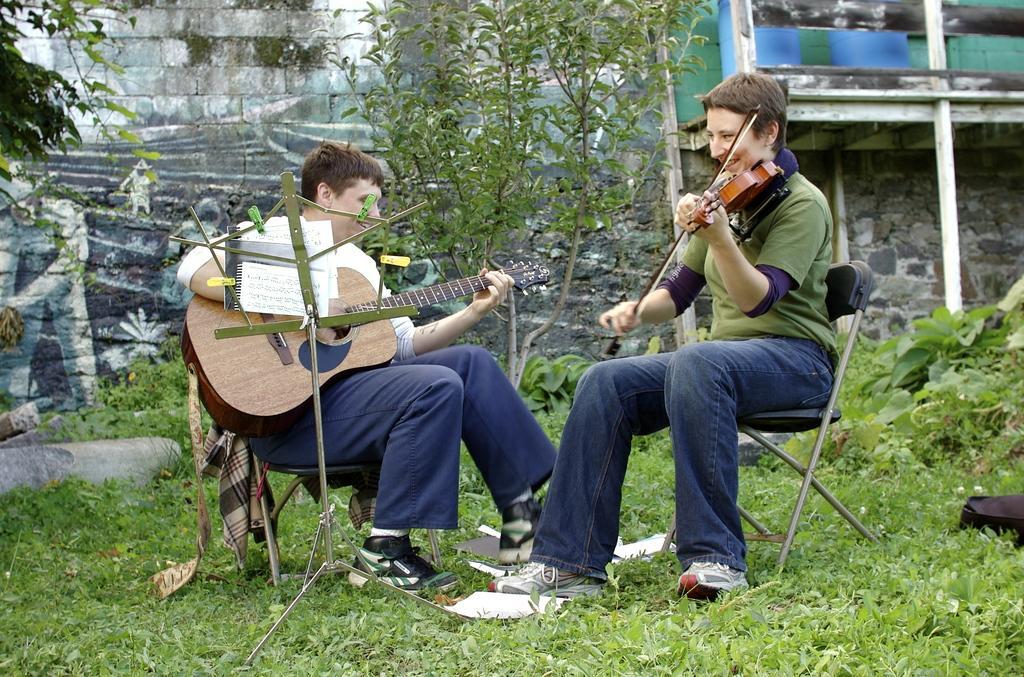Please provide a concise description of this image. This picture shows two men seated on the chair and we see a man playing violin and other man playing guitar and we see a tree and few plants around 